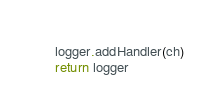<code> <loc_0><loc_0><loc_500><loc_500><_Python_>    logger.addHandler(ch)
    return logger
</code> 